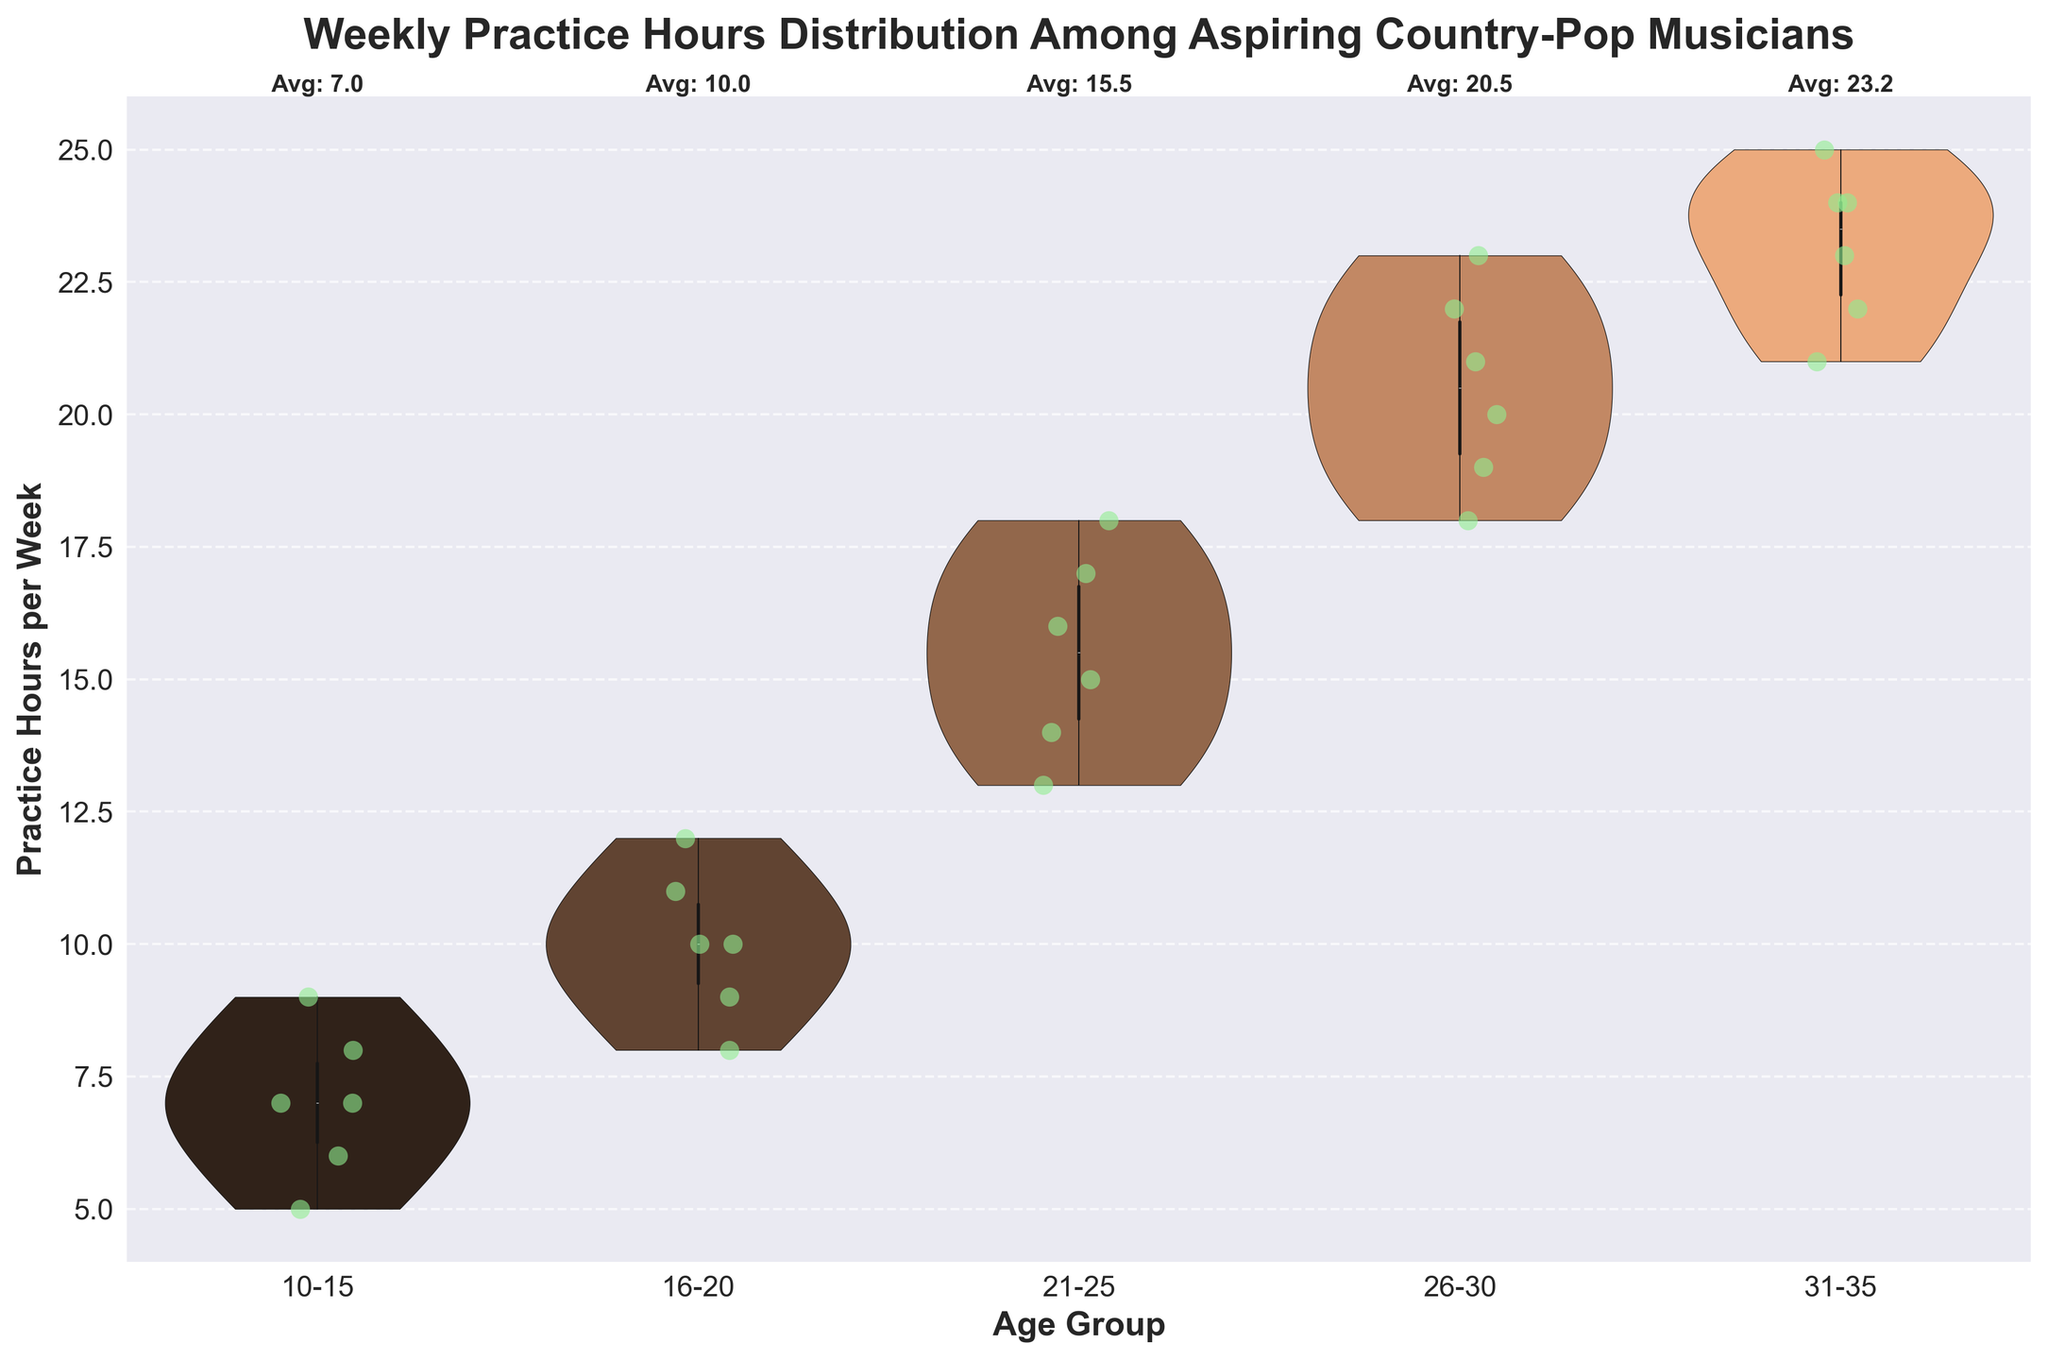What's the title of the plot? The title is typically located at the top of the plot. It summarizes what the chart is about.
Answer: Weekly Practice Hours Distribution Among Aspiring Country-Pop Musicians What age group has the highest average practice hours? From the annotated text at the top of each violin, you can see the average practice hours for each age group. The highest average is labeled at the top of its respective violin.
Answer: 31-35 Which age group has the lowest spread of practice hours? The spread of practice hours can be observed from the width of the violin plot. The narrower the violin plot, the lower the spread.
Answer: 10-15 How many age groups are represented in the plot? Count the distinct categories on the x-axis labeled "Age Group".
Answer: 5 What is the average practice hours for the 21-25 age group? The average practice hours are annotated above the violin for the 21-25 age group.
Answer: 15.5 Are there any age groups with identical average practice hours? Compare the annotated average practice hours for all age groups to check for any identical values.
Answer: No Compare the spread in practice hours between age groups 16-20 and 21-25. Consider the width and shape of the violin plots for age groups 16-20 and 21-25. A wider and longer violin plot indicates more spread. Based on observing both violins, you can infer which has a greater spread.
Answer: 21-25 has a greater spread What color is used for the jittered points in the plot? Observing the data points scattered around the violin plots, you can see their color.
Answer: Light green Which age group has the highest single practice hour value, and what is it? Look at the ends of the violin plots and the jittered points to identify the maximum data point for each group.
Answer: 31-35, 25 hours Is there a noticeable trend in average practice hours as age increases? By looking at the annotated averages from left to right (increasing age), compare the values to see if there is a general increase, decrease, or no trend.
Answer: Yes, the average practice hours increase as age increases 